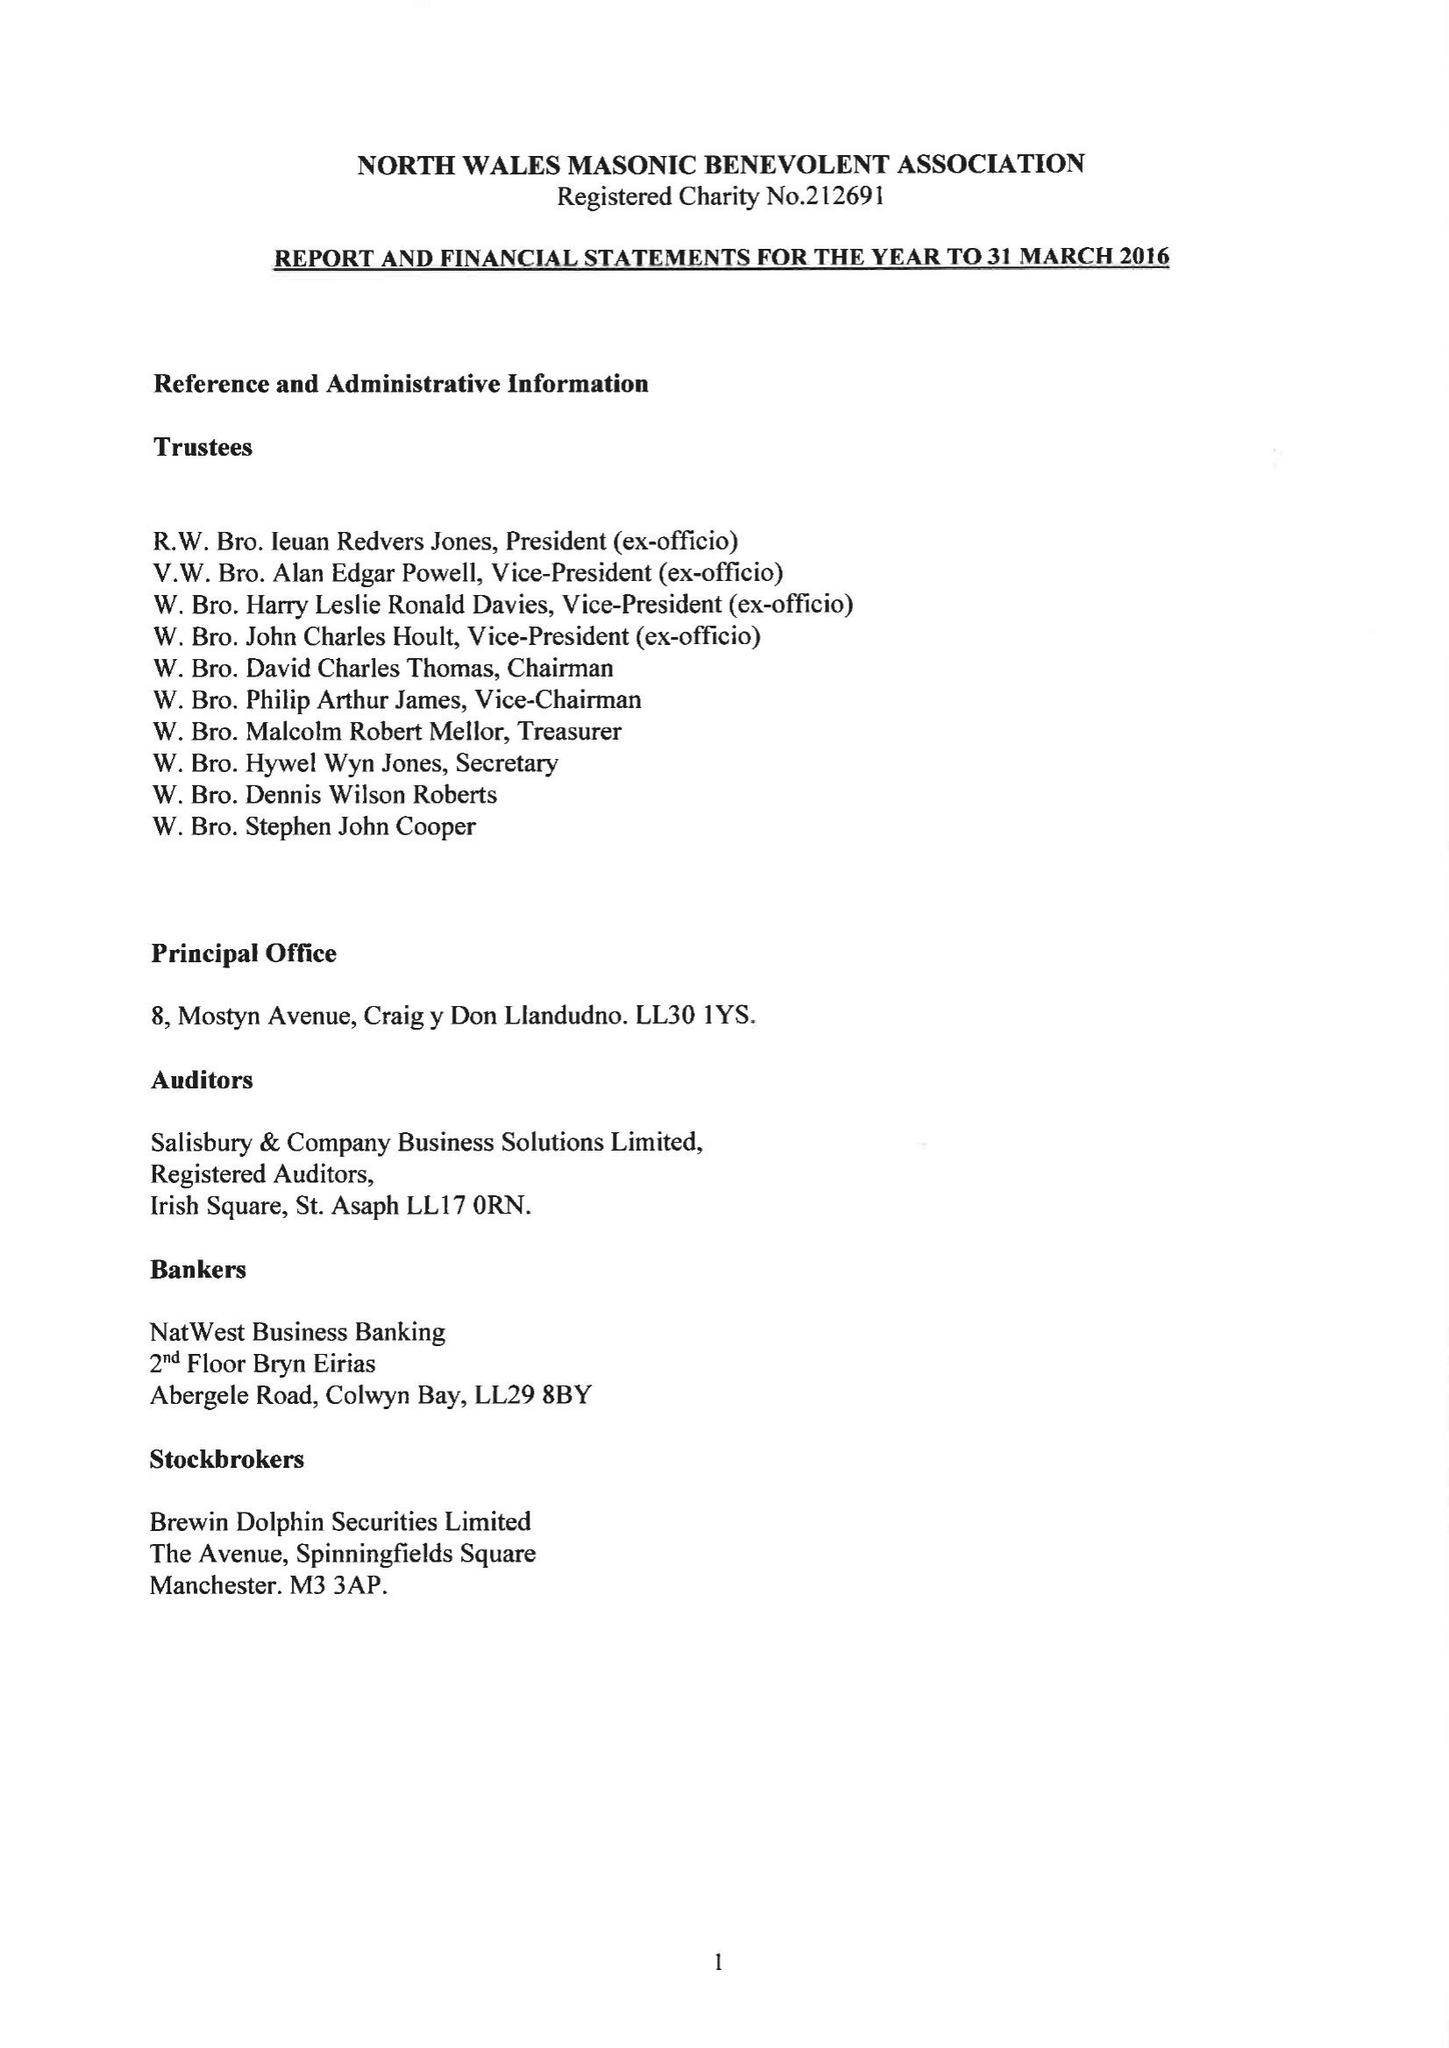What is the value for the income_annually_in_british_pounds?
Answer the question using a single word or phrase. 356046.00 